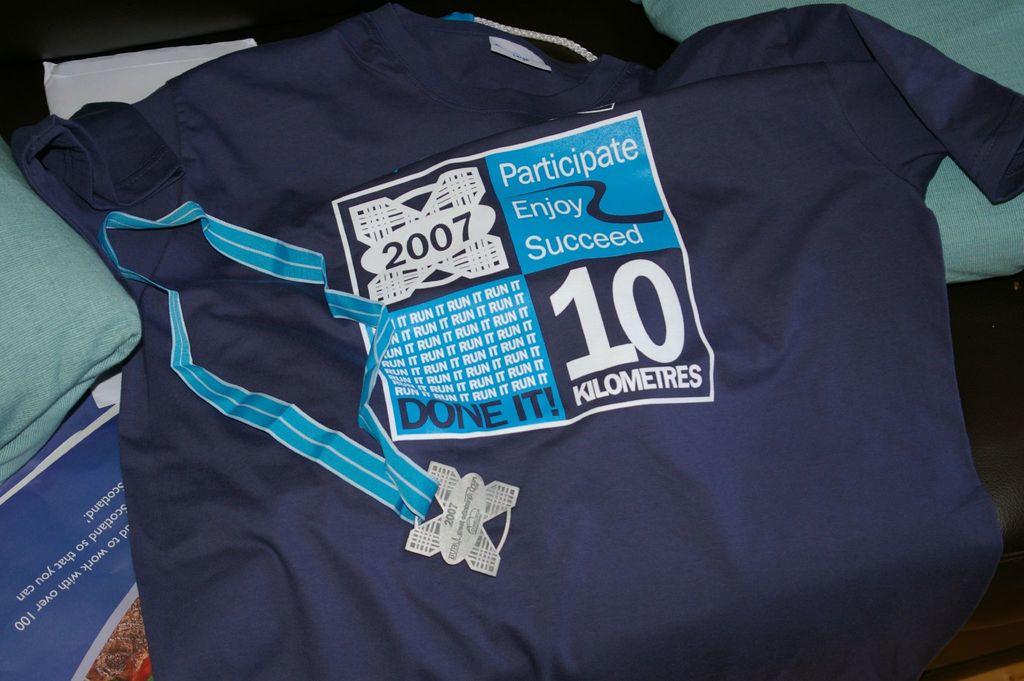What event is the shirt celebrating?
Give a very brief answer. 10 kilometres. How many kilometers was this race?
Make the answer very short. 10. 